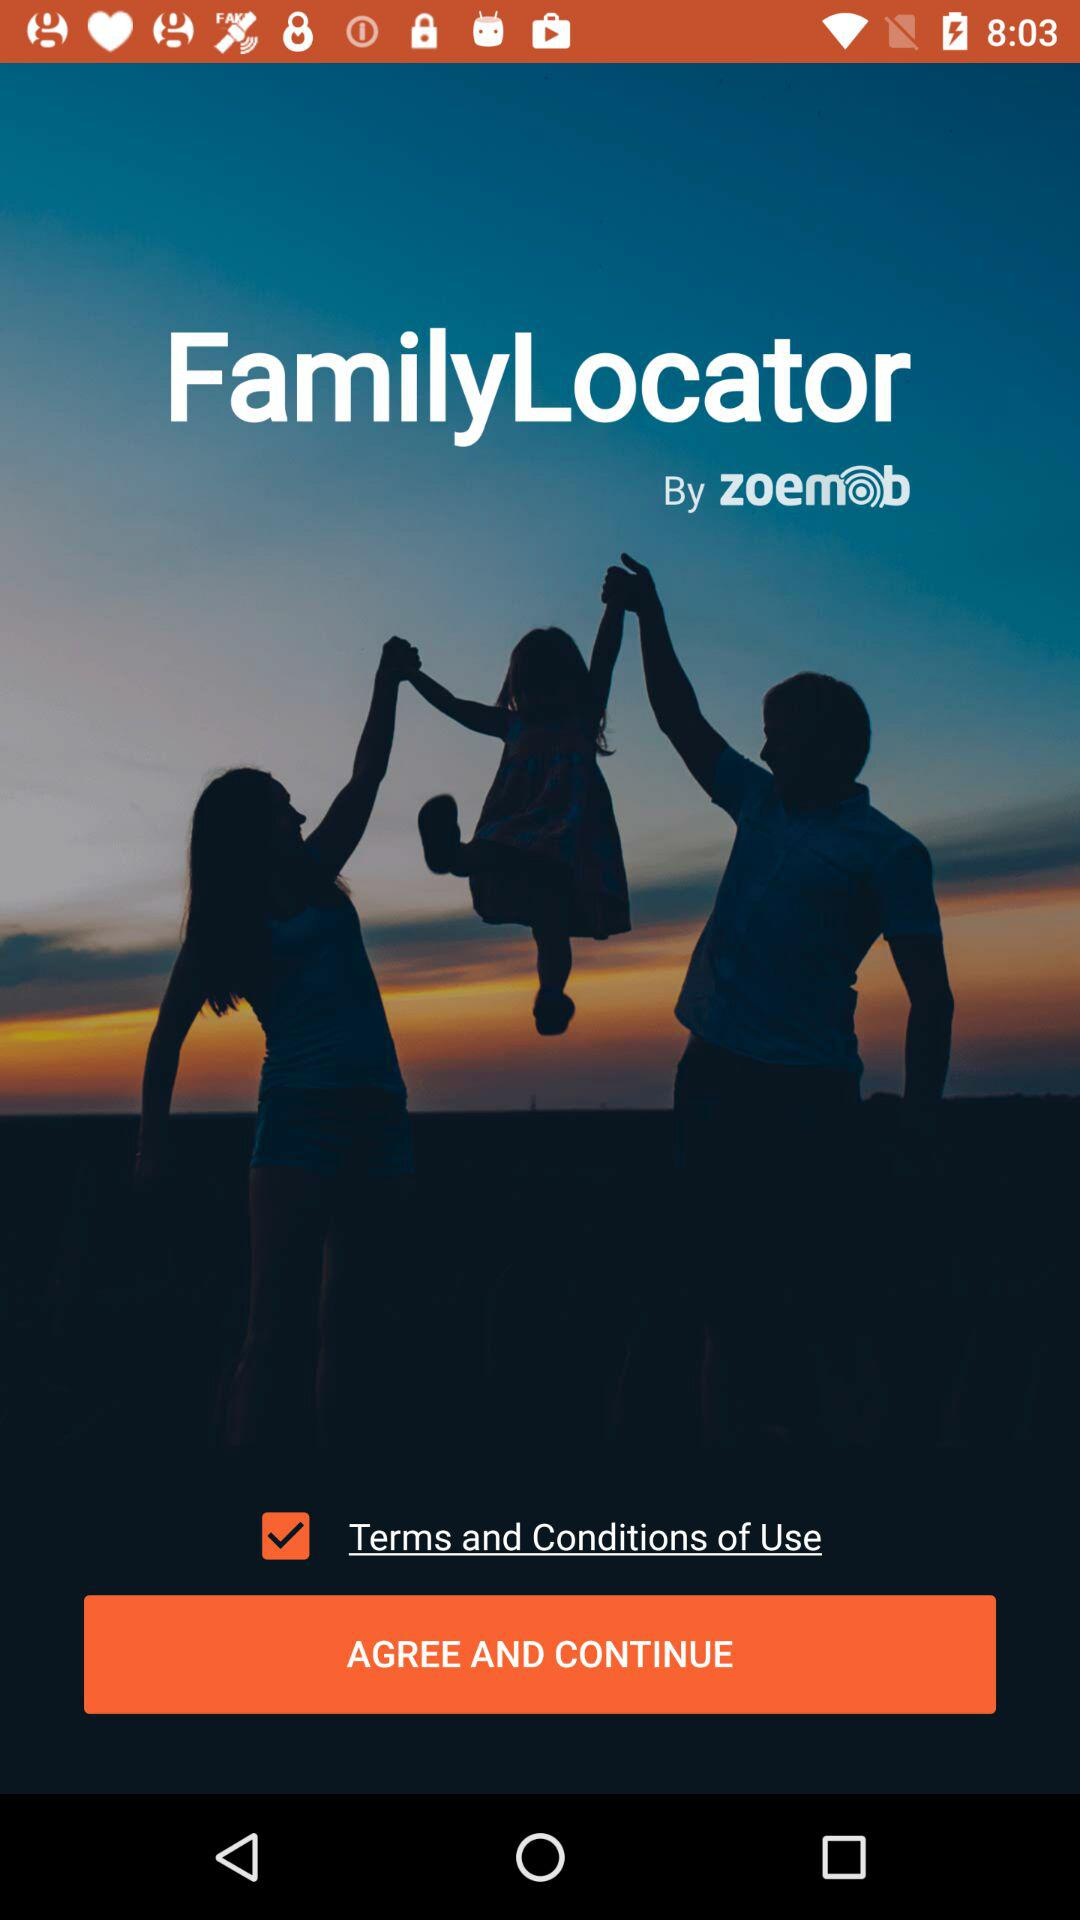What is the status of "Terms and Conditions of Use"? The status is "on". 